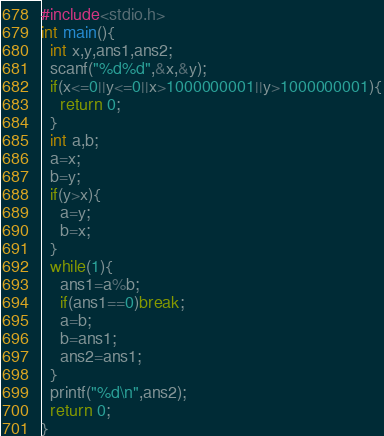Convert code to text. <code><loc_0><loc_0><loc_500><loc_500><_C_>#include<stdio.h>
int main(){
  int x,y,ans1,ans2;
  scanf("%d%d",&x,&y);
  if(x<=0||y<=0||x>1000000001||y>1000000001){
    return 0;
  }
  int a,b;
  a=x;
  b=y;
  if(y>x){
    a=y;
    b=x;
  }
  while(1){
    ans1=a%b;
    if(ans1==0)break;
    a=b;
    b=ans1;
    ans2=ans1;
  }
  printf("%d\n",ans2);
  return 0;
}

</code> 